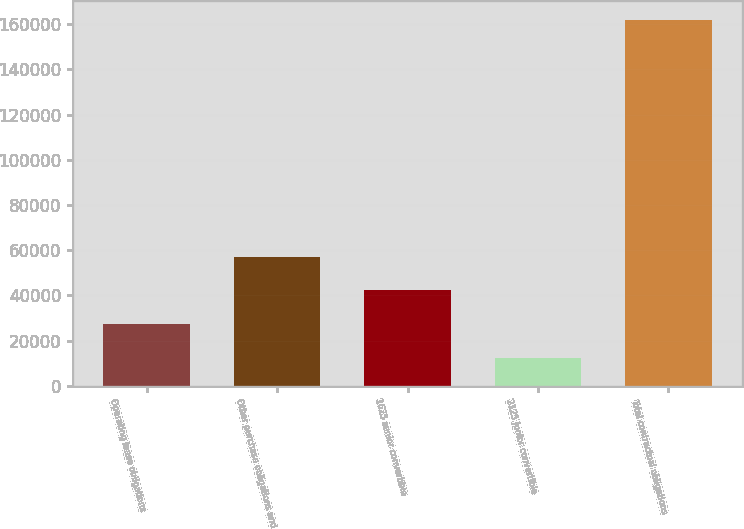<chart> <loc_0><loc_0><loc_500><loc_500><bar_chart><fcel>Operating lease obligations<fcel>Other purchase obligations and<fcel>1625 senior convertible<fcel>2125 junior convertible<fcel>Total contractual obligations<nl><fcel>27191<fcel>57135<fcel>42163<fcel>12219<fcel>161939<nl></chart> 